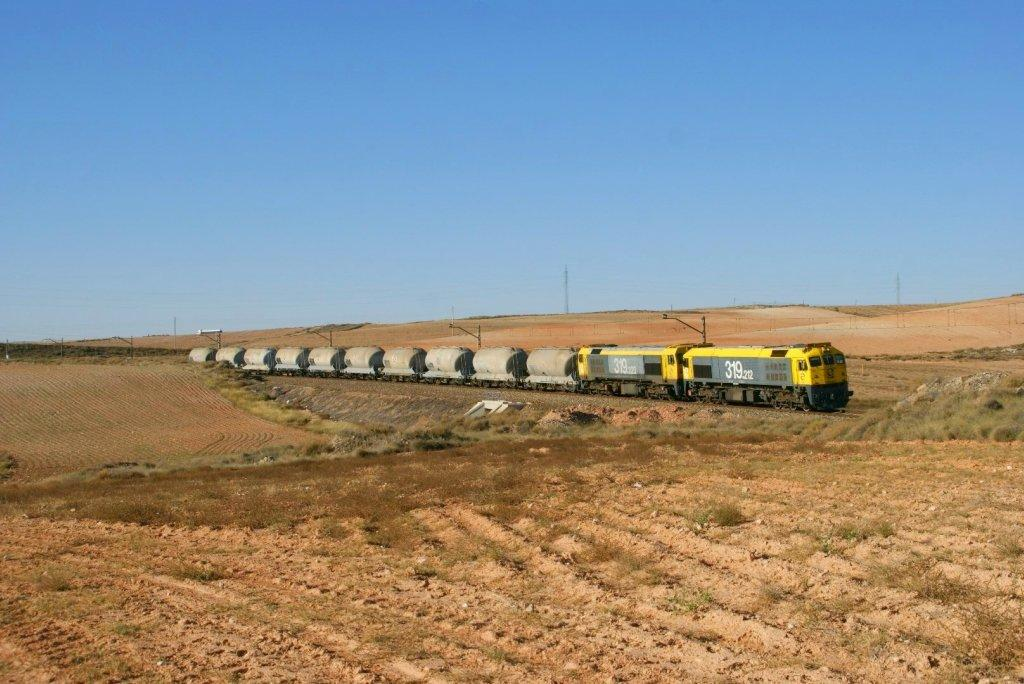What is the main subject of the image? The main subject of the image is a train. Where is the train located in the image? The train is on a track. What else can be seen in the image besides the train? There are plants, poles, and the sky visible in the image. How would you describe the sky in the image? The sky appears to be cloudy in the image. Can you see the face of the person who is burning the beans in the image? There is no person burning beans in the image, nor is there any reference to faces or beans. 